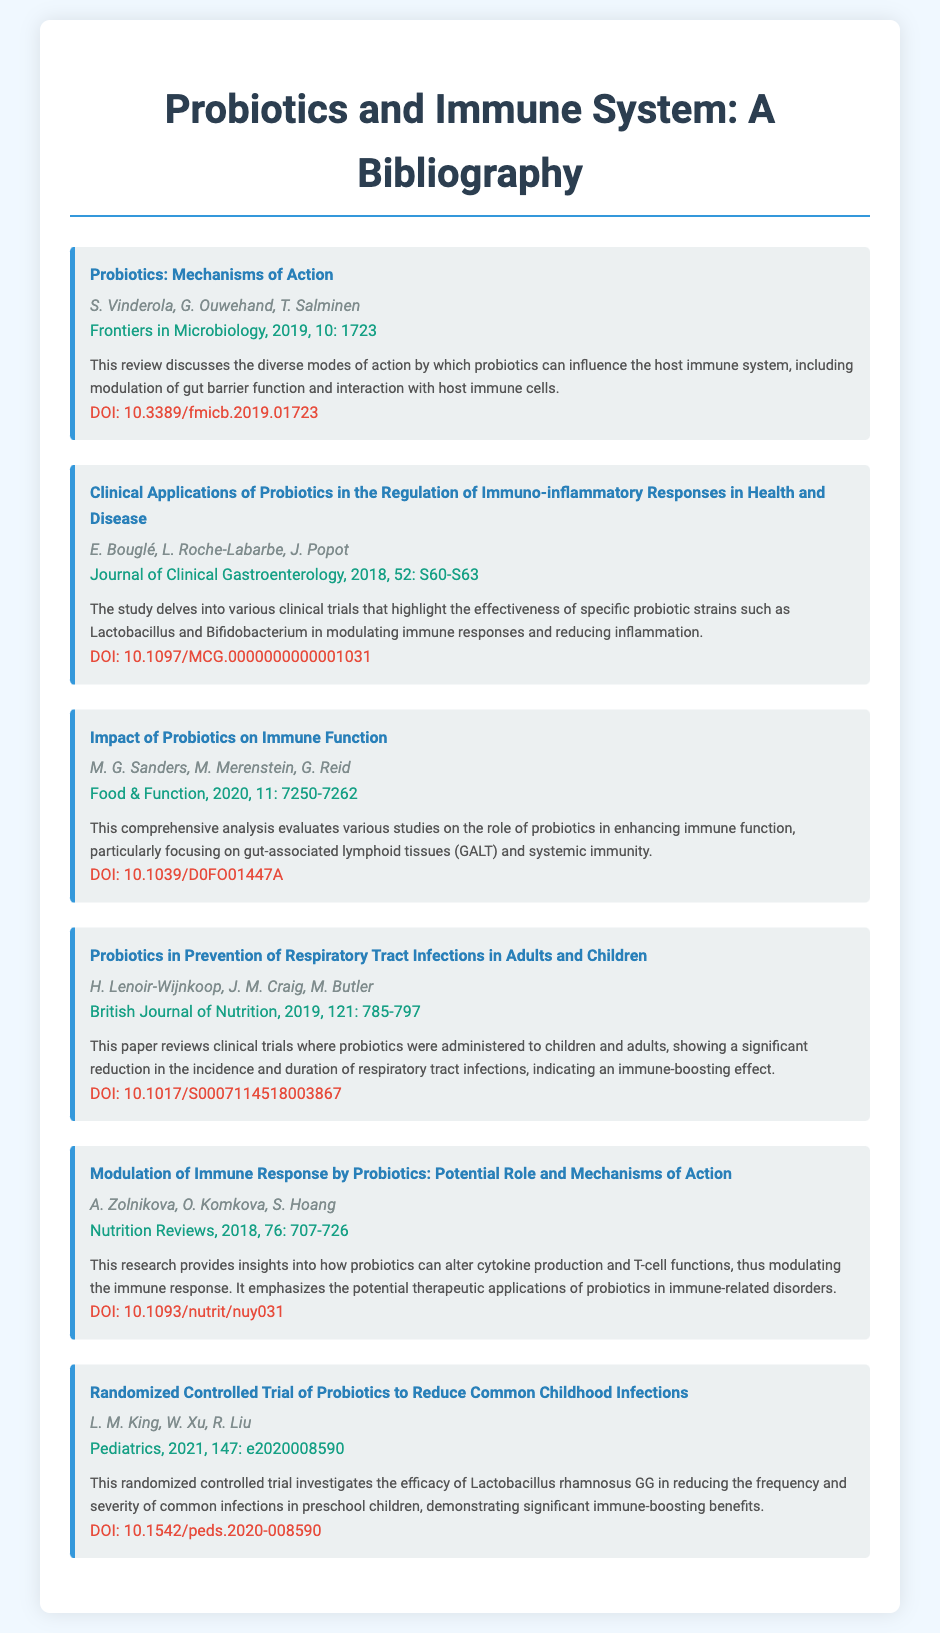what is the title of the first bibliography item? The title of the first bibliography item is listed under the "title" section of the document, which is "Probiotics: Mechanisms of Action."
Answer: Probiotics: Mechanisms of Action who are the authors of the article titled "Clinical Applications of Probiotics in the Regulation of Immuno-inflammatory Responses in Health and Disease"? The authors of the article are mentioned below the title in the bibliography section, which are E. Bouglé, L. Roche-Labarbe, J. Popot.
Answer: E. Bouglé, L. Roche-Labarbe, J. Popot what is the DOI of the publication "Impact of Probiotics on Immune Function"? The DOI is provided at the end of each bibliography item. For "Impact of Probiotics on Immune Function," it is 10.1039/D0FO01447A.
Answer: 10.1039/D0FO01447A which journal published the article by M. G. Sanders, M. Merenstein, G. Reid? The journal name appears in the bibliographic entry, specifically next to the authors' names. The journal is "Food & Function."
Answer: Food & Function what year was the article "Probiotics in Prevention of Respiratory Tract Infections in Adults and Children" published? The publication year is noted next to the journal name in each bibliographic entry, which is 2019 for this specific article.
Answer: 2019 how many authors co-authored the paper titled "Modulation of Immune Response by Probiotics: Potential Role and Mechanisms of Action"? The number of authors is indicated by the names listed under the title of that bibliography item. The article has three authors.
Answer: 3 what clinical outcome did the randomized controlled trial by L. M. King, W. Xu, R. Liu focus on? The outcome focuses on the frequency and severity of common infections in preschool children, as stated in the summary of the item.
Answer: Common infections which probiotic strain was studied in the randomized controlled trial mentioned in the last bibliography item? The specific strain studied is noted within the summary of the bibliographic entry, which is Lactobacillus rhamnosus GG.
Answer: Lactobacillus rhamnosus GG what is the primary focus of the bibliography? The overall theme and focus can be deduced from the title and summaries, which encompass the role of probiotics in enhancing immune system function.
Answer: Probiotics and immune function 